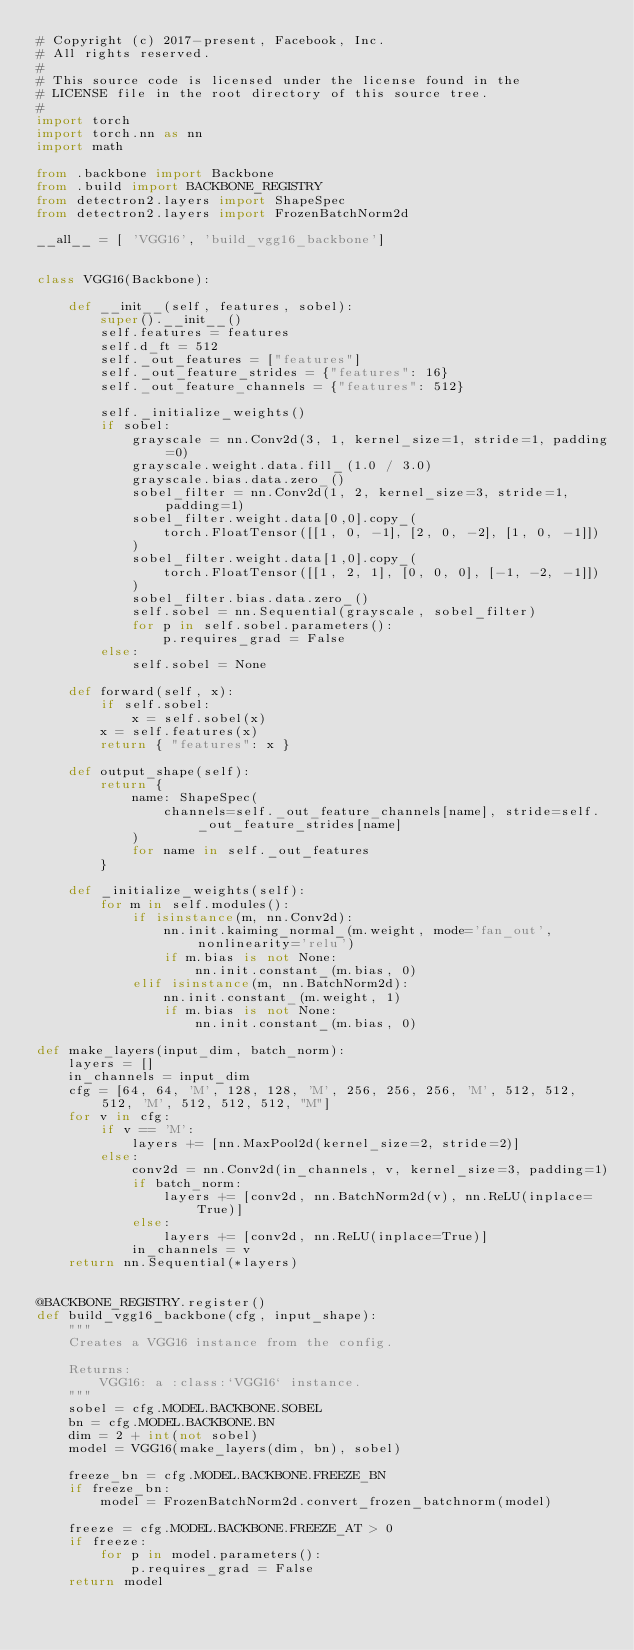<code> <loc_0><loc_0><loc_500><loc_500><_Python_># Copyright (c) 2017-present, Facebook, Inc.
# All rights reserved.
#
# This source code is licensed under the license found in the
# LICENSE file in the root directory of this source tree.
#
import torch
import torch.nn as nn
import math

from .backbone import Backbone
from .build import BACKBONE_REGISTRY
from detectron2.layers import ShapeSpec
from detectron2.layers import FrozenBatchNorm2d

__all__ = [ 'VGG16', 'build_vgg16_backbone']


class VGG16(Backbone):

    def __init__(self, features, sobel):
        super().__init__()
        self.features = features
        self.d_ft = 512
        self._out_features = ["features"]
        self._out_feature_strides = {"features": 16}
        self._out_feature_channels = {"features": 512}

        self._initialize_weights()
        if sobel:
            grayscale = nn.Conv2d(3, 1, kernel_size=1, stride=1, padding=0)
            grayscale.weight.data.fill_(1.0 / 3.0)
            grayscale.bias.data.zero_()
            sobel_filter = nn.Conv2d(1, 2, kernel_size=3, stride=1, padding=1)
            sobel_filter.weight.data[0,0].copy_(
                torch.FloatTensor([[1, 0, -1], [2, 0, -2], [1, 0, -1]])
            )
            sobel_filter.weight.data[1,0].copy_(
                torch.FloatTensor([[1, 2, 1], [0, 0, 0], [-1, -2, -1]])
            )
            sobel_filter.bias.data.zero_()
            self.sobel = nn.Sequential(grayscale, sobel_filter)
            for p in self.sobel.parameters():
                p.requires_grad = False
        else:
            self.sobel = None

    def forward(self, x):
        if self.sobel:
            x = self.sobel(x)
        x = self.features(x)
        return { "features": x }

    def output_shape(self):
        return {
            name: ShapeSpec(
                channels=self._out_feature_channels[name], stride=self._out_feature_strides[name]
            )
            for name in self._out_features
        }

    def _initialize_weights(self):
        for m in self.modules():
            if isinstance(m, nn.Conv2d):
                nn.init.kaiming_normal_(m.weight, mode='fan_out', nonlinearity='relu')
                if m.bias is not None:
                    nn.init.constant_(m.bias, 0)
            elif isinstance(m, nn.BatchNorm2d):
                nn.init.constant_(m.weight, 1)
                if m.bias is not None:
                    nn.init.constant_(m.bias, 0)

def make_layers(input_dim, batch_norm):
    layers = []
    in_channels = input_dim
    cfg = [64, 64, 'M', 128, 128, 'M', 256, 256, 256, 'M', 512, 512, 512, 'M', 512, 512, 512, "M"] 
    for v in cfg:
        if v == 'M':
            layers += [nn.MaxPool2d(kernel_size=2, stride=2)]
        else:
            conv2d = nn.Conv2d(in_channels, v, kernel_size=3, padding=1)
            if batch_norm:
                layers += [conv2d, nn.BatchNorm2d(v), nn.ReLU(inplace=True)]
            else:
                layers += [conv2d, nn.ReLU(inplace=True)]
            in_channels = v
    return nn.Sequential(*layers)


@BACKBONE_REGISTRY.register()
def build_vgg16_backbone(cfg, input_shape):
    """
    Creates a VGG16 instance from the config.

    Returns:
        VGG16: a :class:`VGG16` instance.
    """
    sobel = cfg.MODEL.BACKBONE.SOBEL
    bn = cfg.MODEL.BACKBONE.BN
    dim = 2 + int(not sobel)
    model = VGG16(make_layers(dim, bn), sobel)
    
    freeze_bn = cfg.MODEL.BACKBONE.FREEZE_BN
    if freeze_bn:
        model = FrozenBatchNorm2d.convert_frozen_batchnorm(model)

    freeze = cfg.MODEL.BACKBONE.FREEZE_AT > 0
    if freeze:
        for p in model.parameters():
            p.requires_grad = False
    return model

</code> 